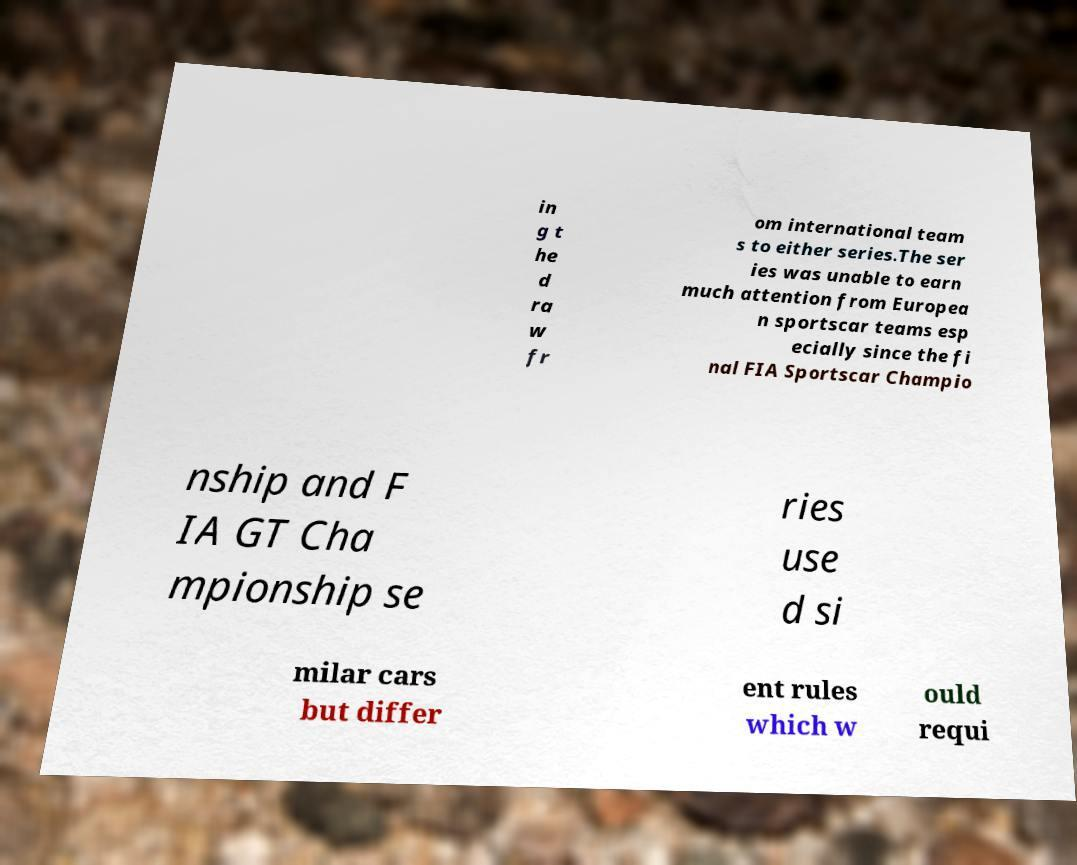Can you read and provide the text displayed in the image?This photo seems to have some interesting text. Can you extract and type it out for me? in g t he d ra w fr om international team s to either series.The ser ies was unable to earn much attention from Europea n sportscar teams esp ecially since the fi nal FIA Sportscar Champio nship and F IA GT Cha mpionship se ries use d si milar cars but differ ent rules which w ould requi 